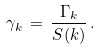<formula> <loc_0><loc_0><loc_500><loc_500>\gamma _ { k } \, = \, \frac { \Gamma _ { k } } { S ( k ) } \, .</formula> 